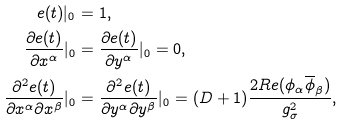<formula> <loc_0><loc_0><loc_500><loc_500>e ( t ) | _ { 0 } & = 1 , \\ \frac { \partial e ( t ) } { \partial x ^ { \alpha } } | _ { 0 } & = \frac { \partial e ( t ) } { \partial y ^ { \alpha } } | _ { 0 } = 0 , \\ \frac { \partial ^ { 2 } e ( t ) } { \partial x ^ { \alpha } \partial x ^ { \beta } } | _ { 0 } & = \frac { \partial ^ { 2 } e ( t ) } { \partial y ^ { \alpha } \partial y ^ { \beta } } | _ { 0 } = ( D + 1 ) \frac { 2 R e ( \phi _ { \alpha } \overline { \phi } _ { \beta } ) } { g _ { \sigma } ^ { 2 } } ,</formula> 